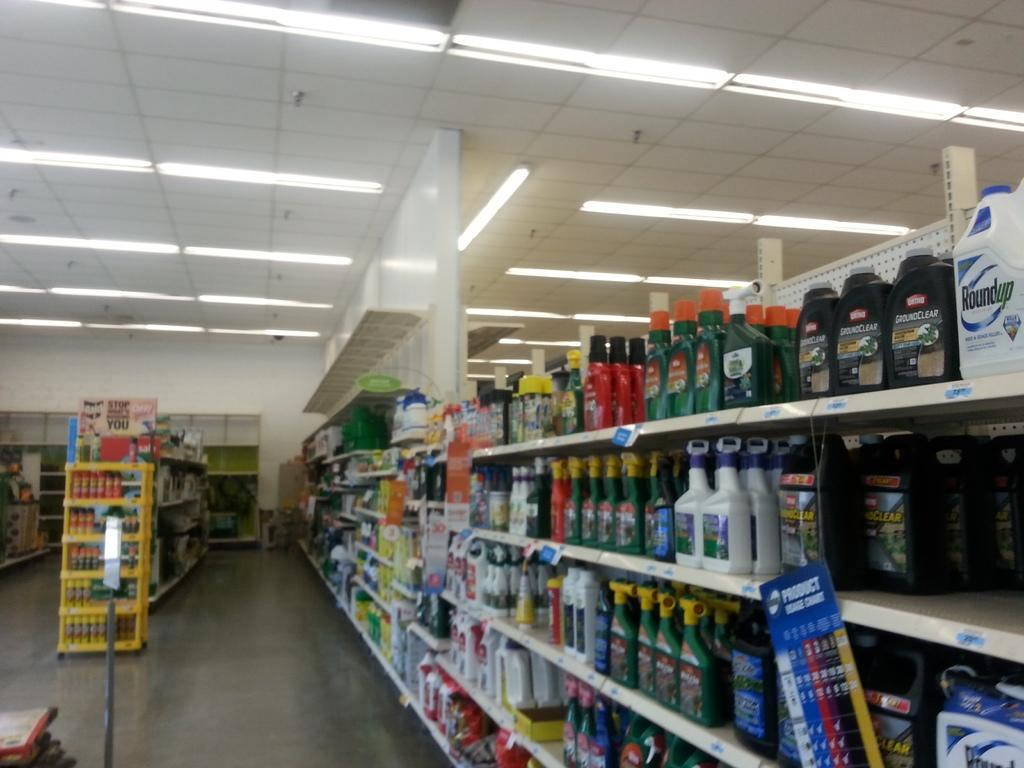<image>
Share a concise interpretation of the image provided. A bottle of Roundup and a bottle of Groundclear. 